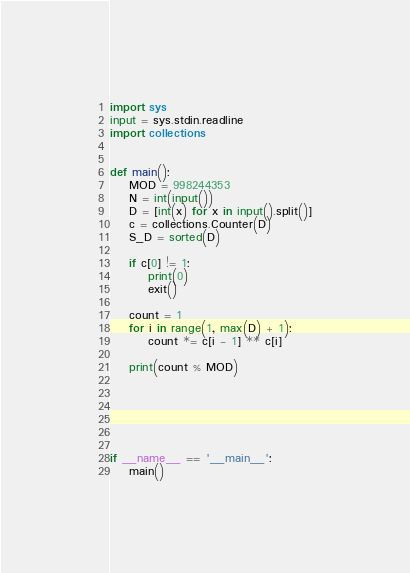Convert code to text. <code><loc_0><loc_0><loc_500><loc_500><_Python_>import sys
input = sys.stdin.readline
import collections


def main():
    MOD = 998244353
    N = int(input())
    D = [int(x) for x in input().split()]
    c = collections.Counter(D)
    S_D = sorted(D)

    if c[0] != 1:
        print(0)
        exit()

    count = 1
    for i in range(1, max(D) + 1):
        count *= c[i - 1] ** c[i]

    print(count % MOD)




    

if __name__ == '__main__':
    main()

</code> 